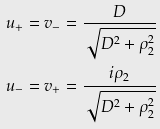Convert formula to latex. <formula><loc_0><loc_0><loc_500><loc_500>u _ { + } & = v _ { - } = \frac { D } { \sqrt { D ^ { 2 } + \rho _ { 2 } ^ { 2 } } } \\ u _ { - } & = v _ { + } = \frac { i \rho _ { 2 } } { \sqrt { D ^ { 2 } + \rho _ { 2 } ^ { 2 } } }</formula> 